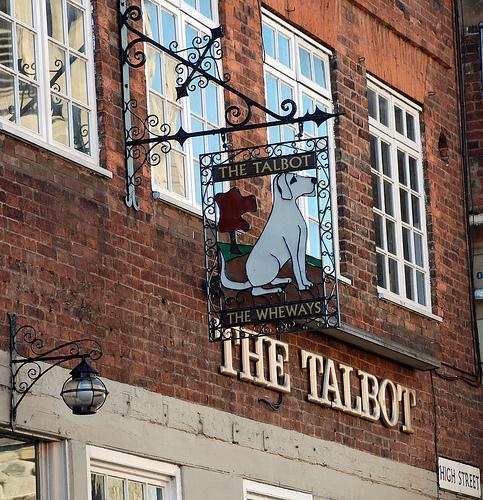How many windows are on the second floor?
Give a very brief answer. 4. 